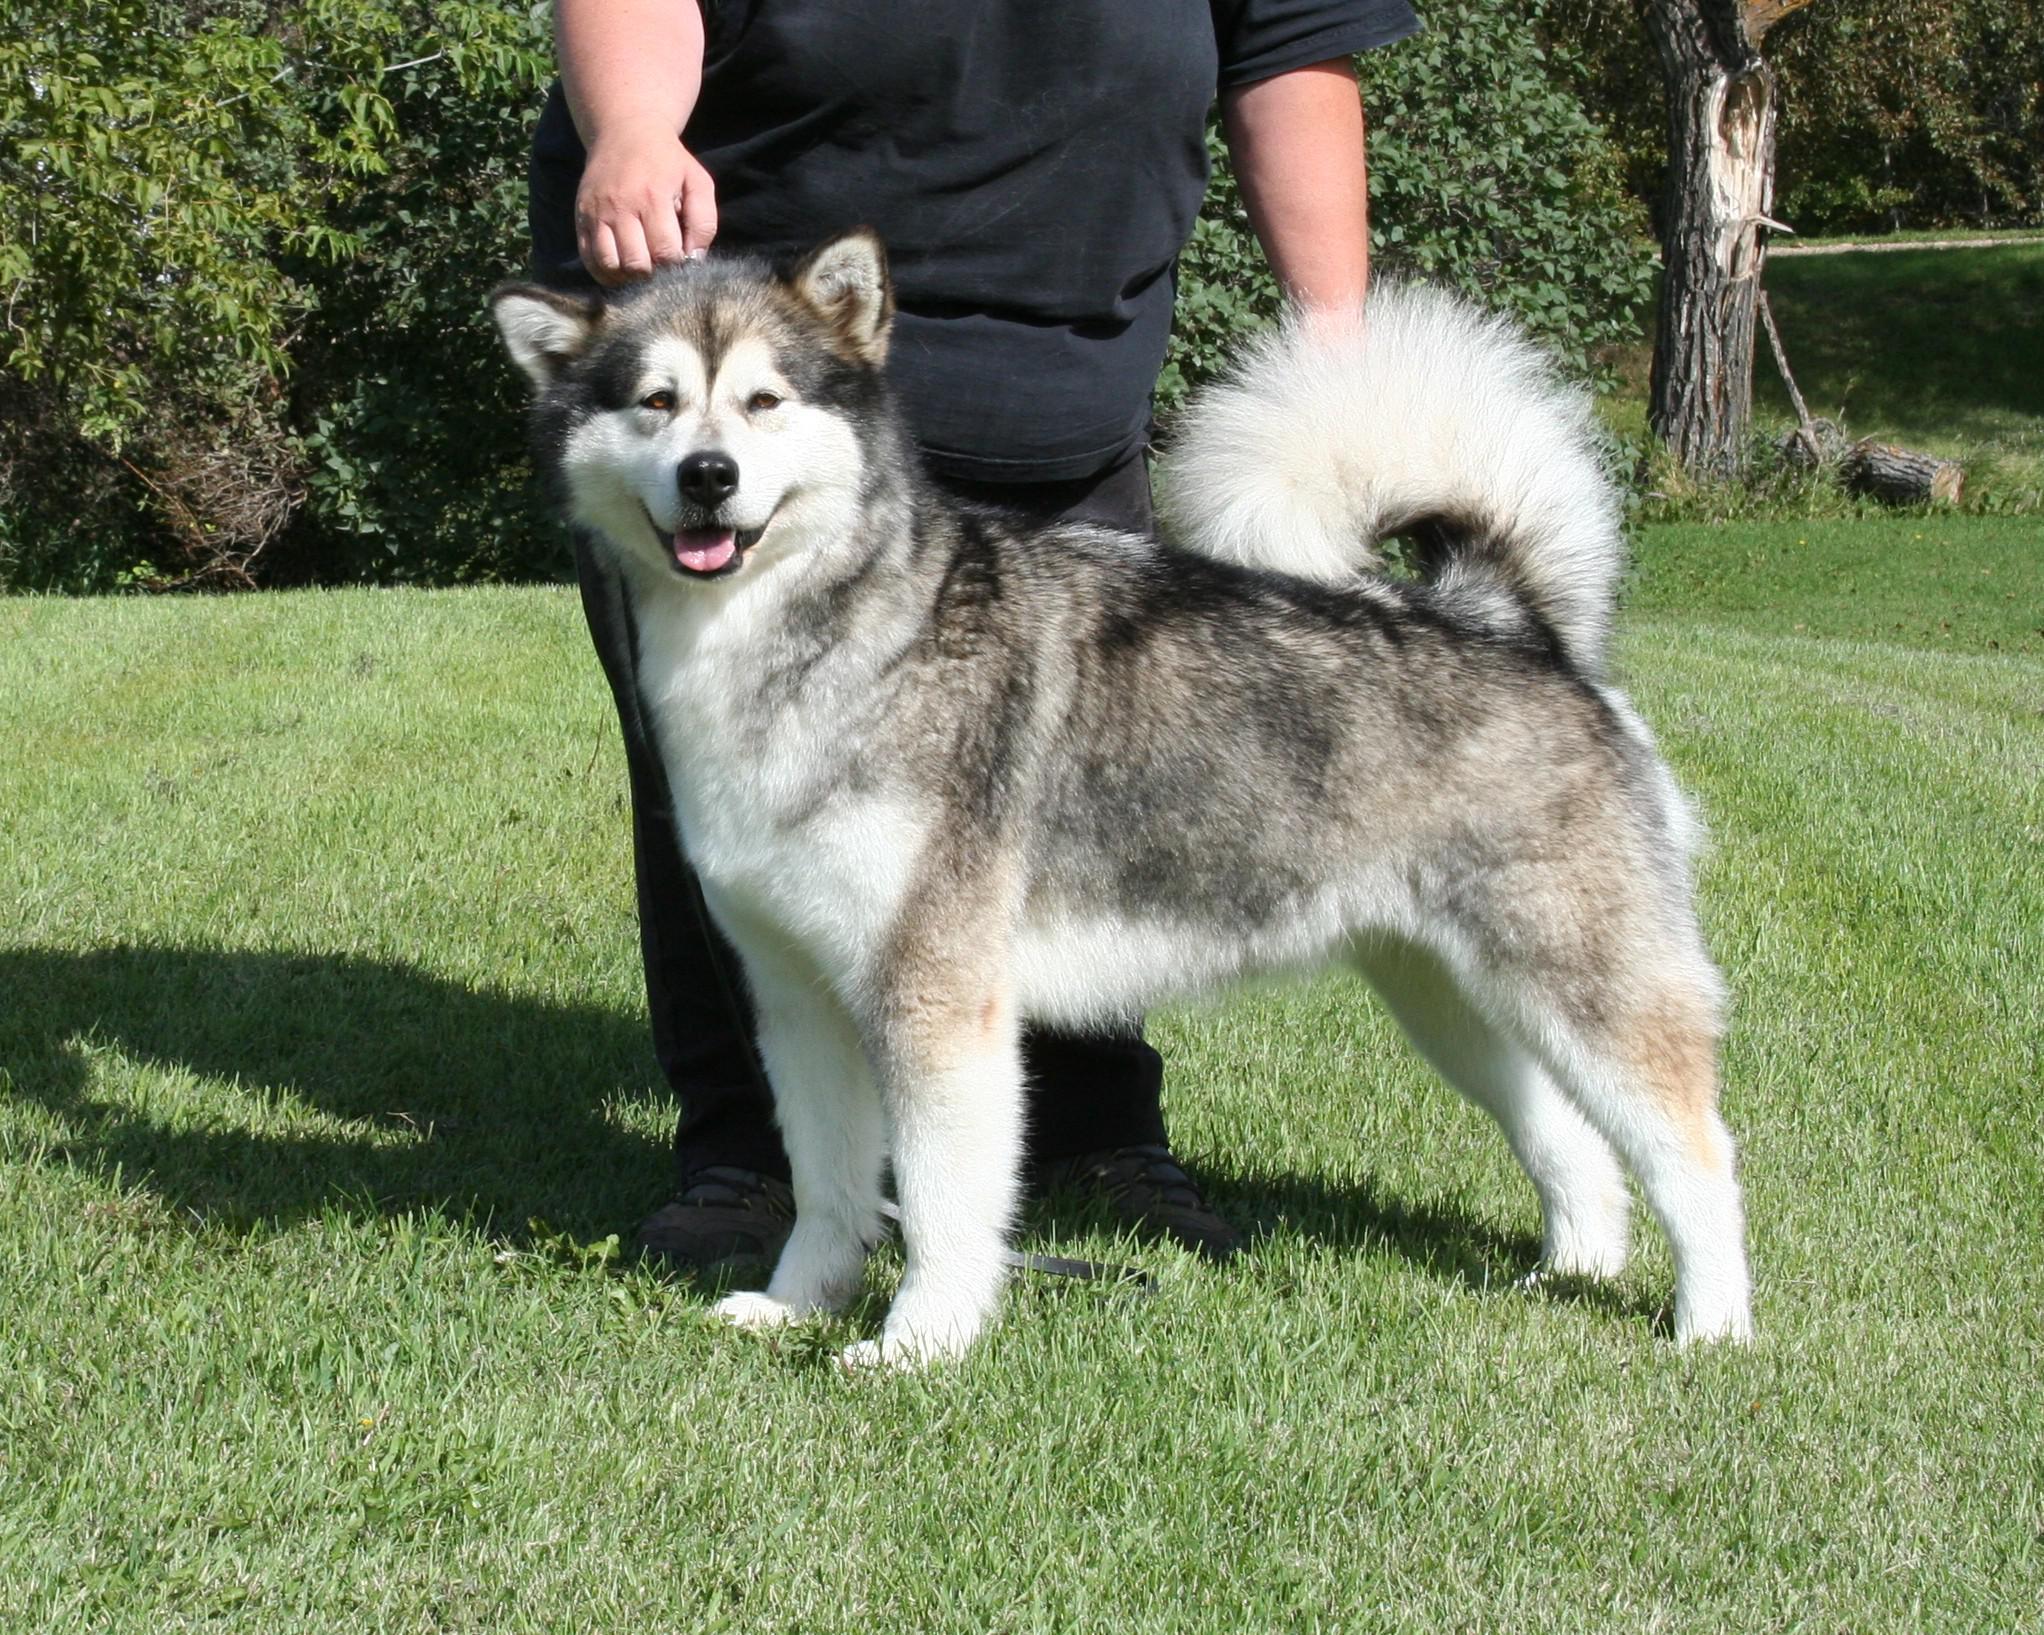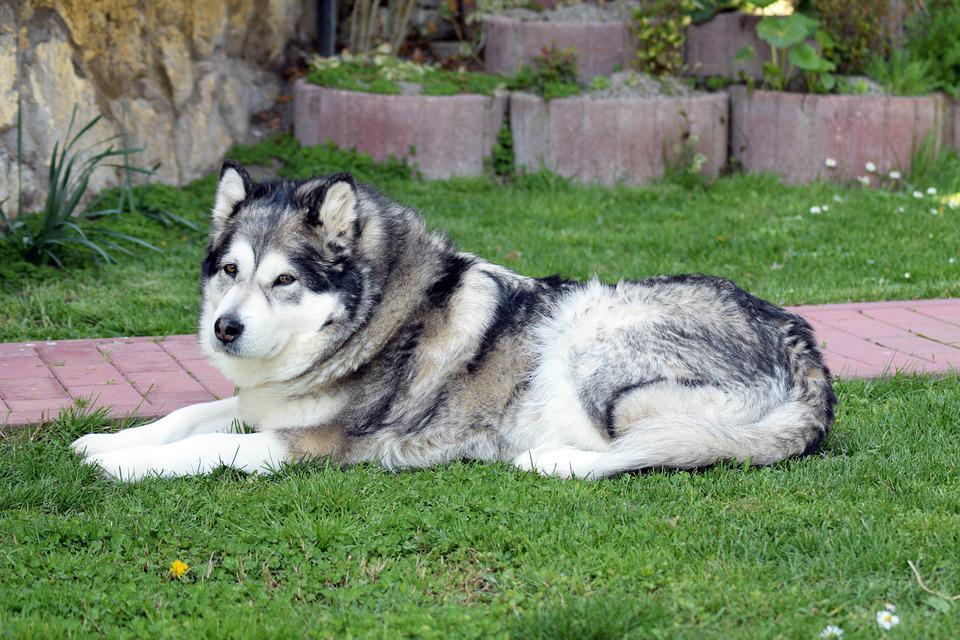The first image is the image on the left, the second image is the image on the right. Given the left and right images, does the statement "The right image contains at least two dogs." hold true? Answer yes or no. No. The first image is the image on the left, the second image is the image on the right. Given the left and right images, does the statement "There are less than 4 dogs" hold true? Answer yes or no. Yes. 